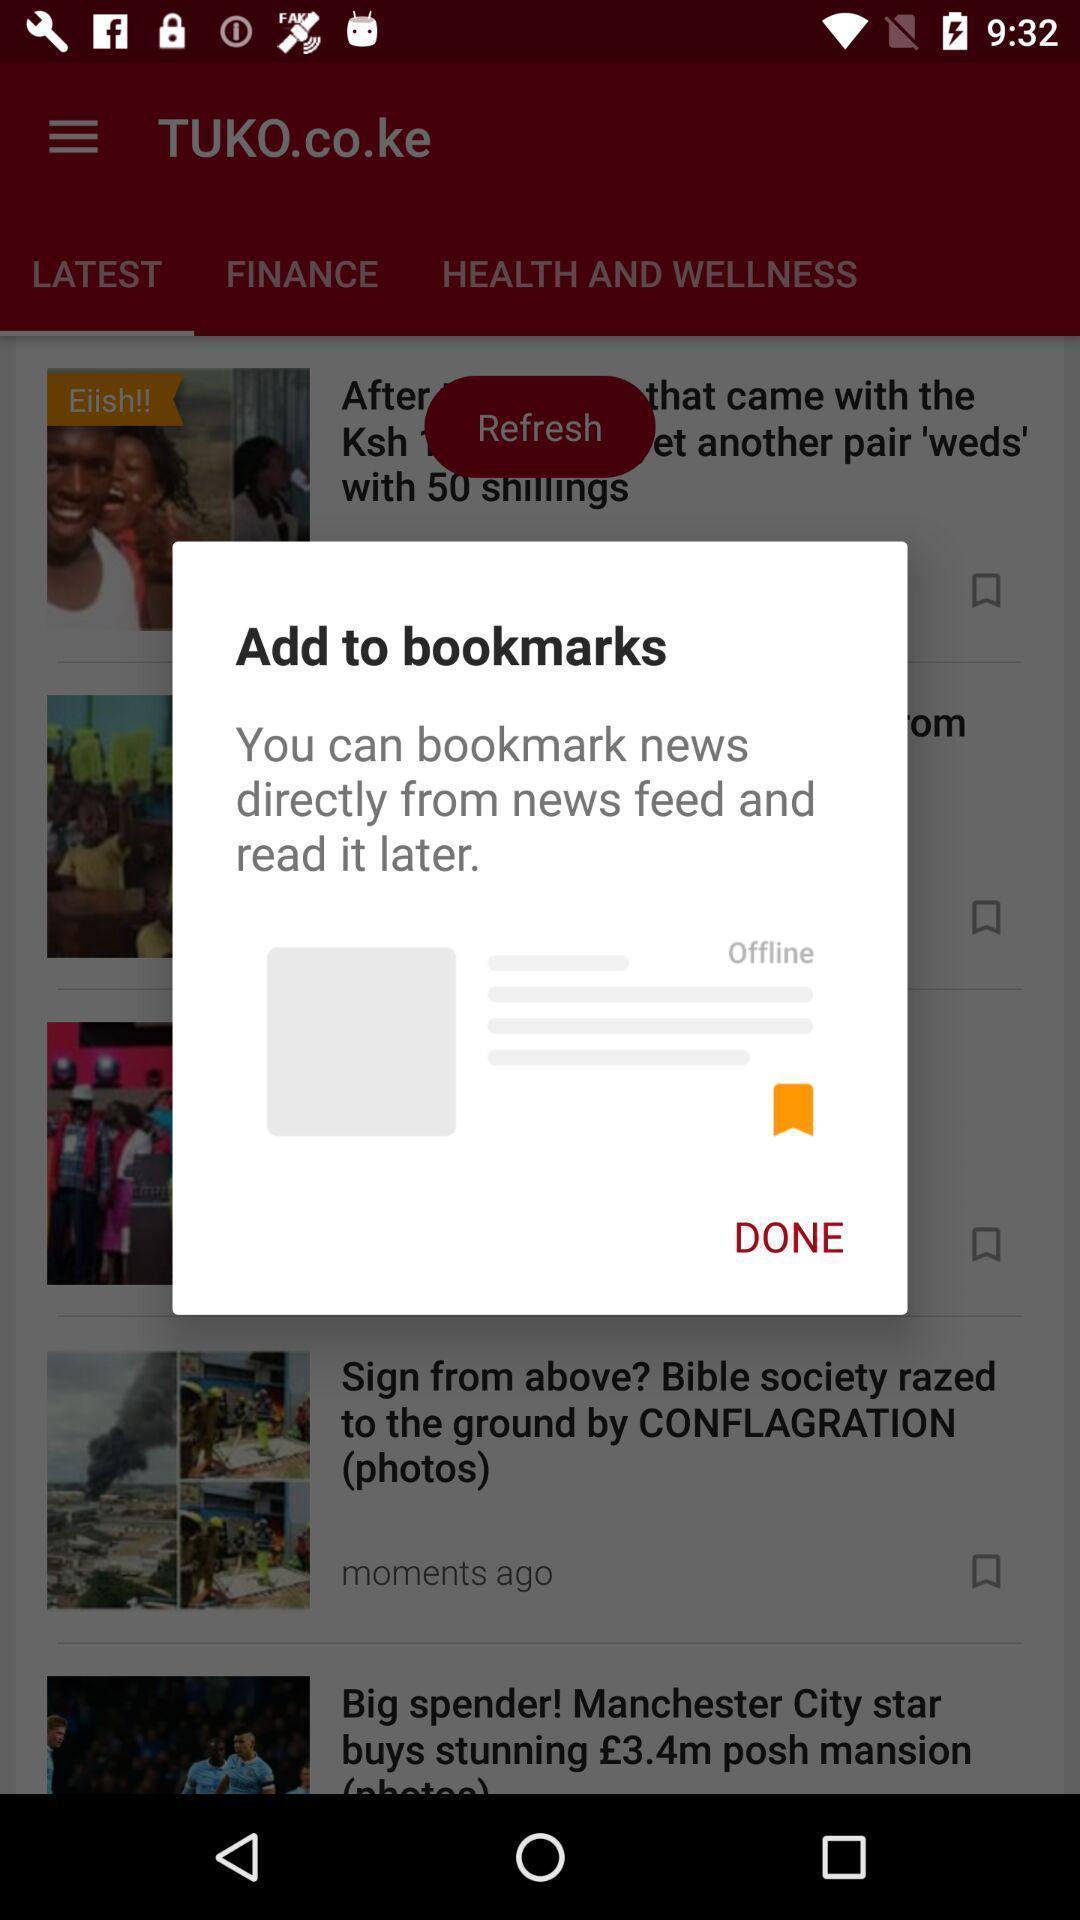What details can you identify in this image? Pop-up showing a way to bookmark the news. 